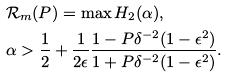Convert formula to latex. <formula><loc_0><loc_0><loc_500><loc_500>& \mathcal { R } _ { m } ( P ) = \max H _ { 2 } ( \alpha ) , \\ & \alpha > \frac { 1 } { 2 } + \frac { 1 } { 2 \epsilon } \frac { 1 - P \delta ^ { - 2 } ( 1 - \epsilon ^ { 2 } ) } { 1 + P \delta ^ { - 2 } ( 1 - \epsilon ^ { 2 } ) } .</formula> 